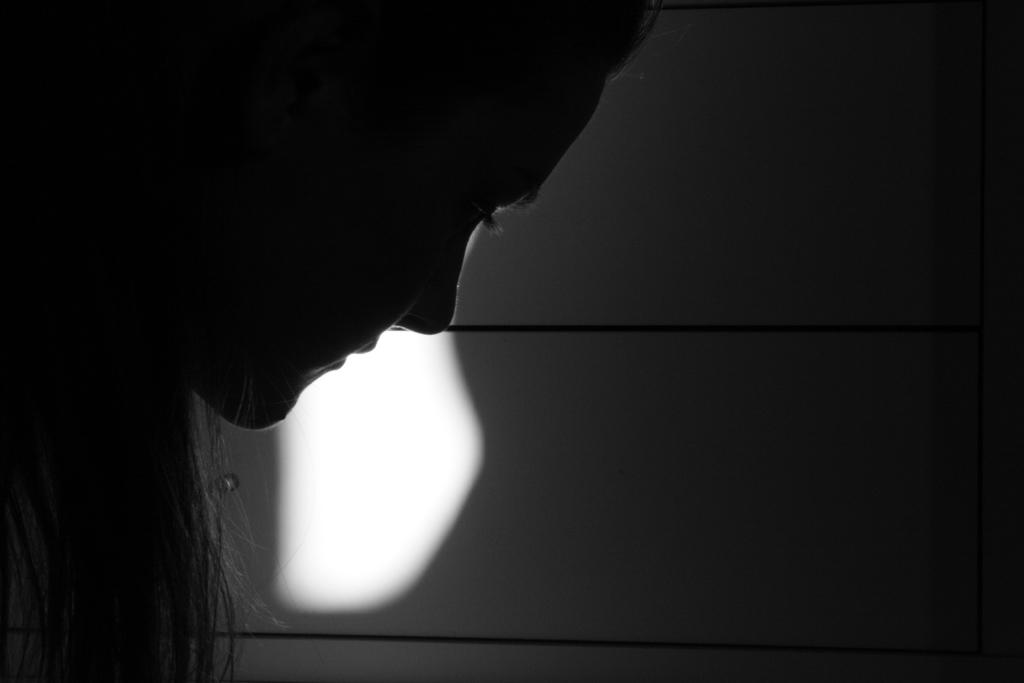What is the color scheme of the image? The image is black and white. What can be seen in the background of the image? There is a wall in the background of the image. Where is the woman located in the image? The woman is on the left side of the image. How many snails can be seen crawling on the wall in the image? There are no snails present in the image; it only features a woman and a wall in the background. 